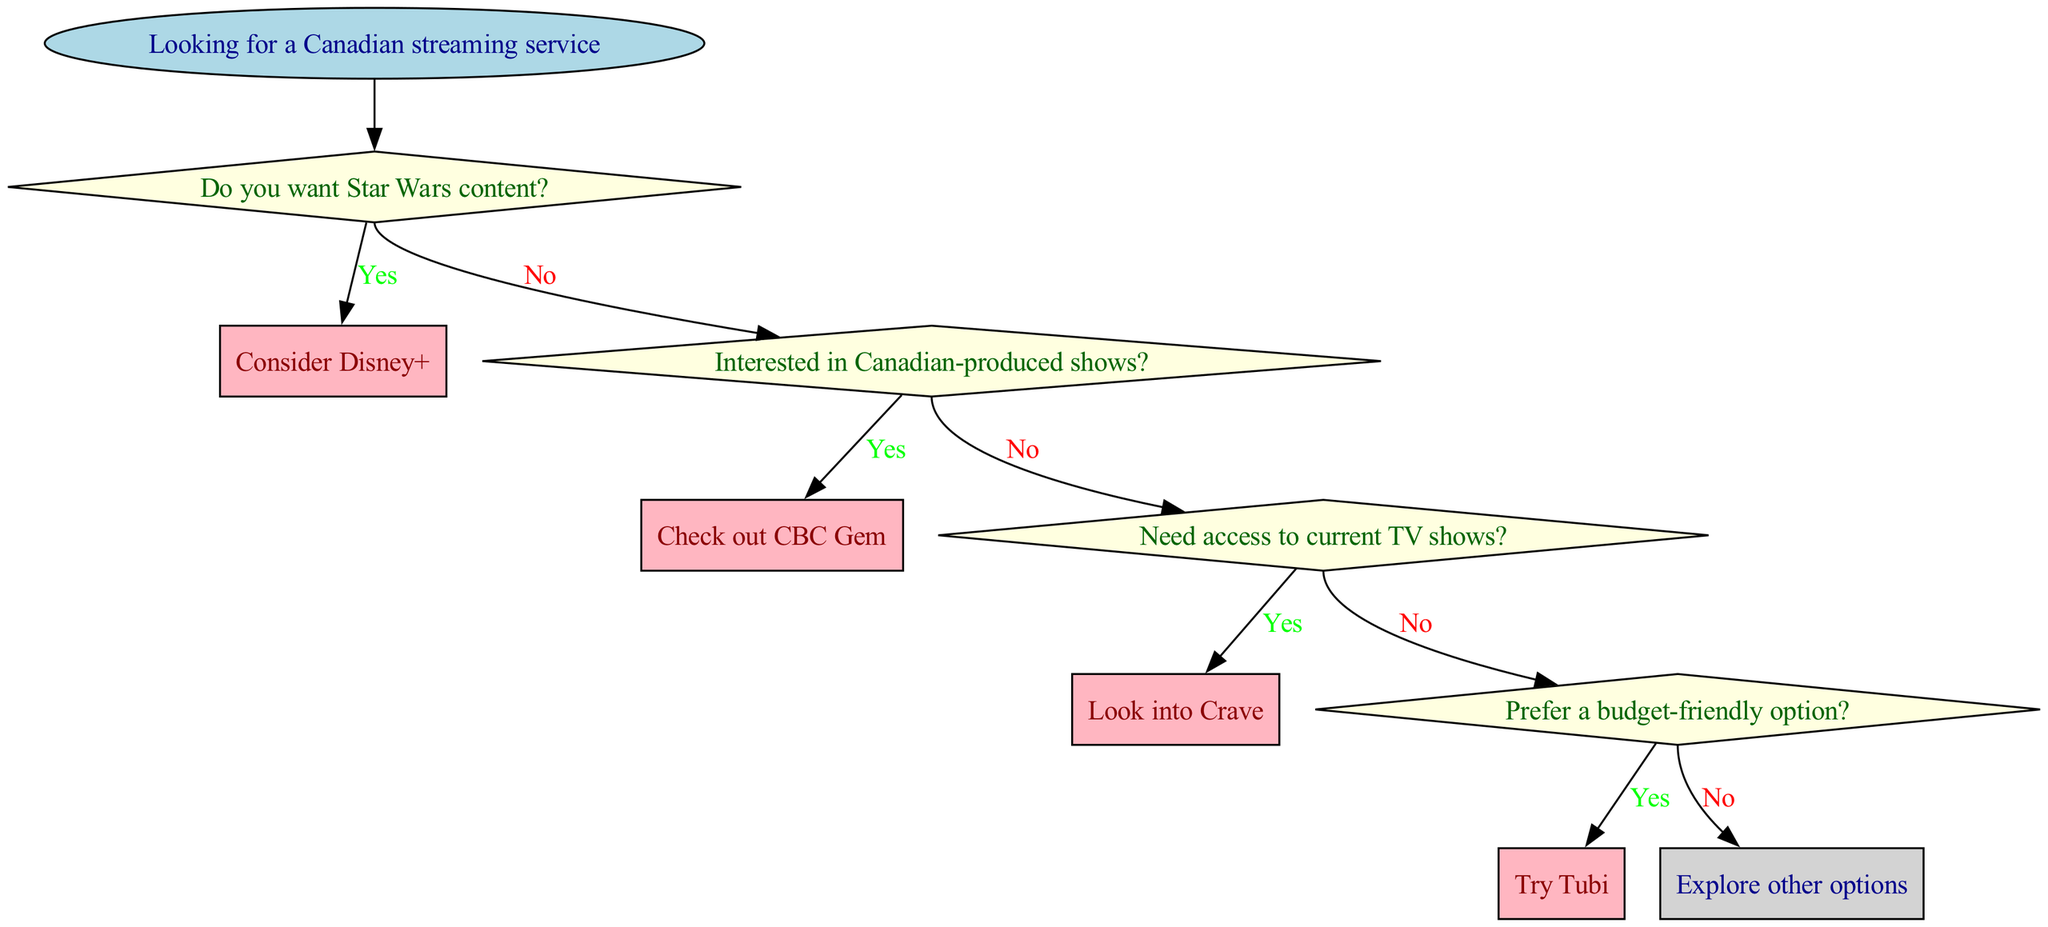What is the first question asked in the flowchart? The first question in the flowchart is directly linked to the starting point, which is "Do you want Star Wars content?" This is the first decision point in the flow.
Answer: Do you want Star Wars content? How many decisions are represented in the diagram? The diagram contains four decision nodes, where users have to answer questions to guide their selection of a streaming service. Each decision node corresponds to a unique question.
Answer: Four If a user answers "no" to the first question, what is the next question they will encounter? After a "no" answer to the first question about Star Wars content, the next question to be encountered is "Interested in Canadian-produced shows?" as it follows sequentially in the flow.
Answer: Interested in Canadian-produced shows? What happens if a user answers "yes" to the question about Canadian-produced shows? If a user answers "yes" to the question about Canadian-produced shows, they are directed to subscribe to CBC Gem, which is the endpoint for that decision.
Answer: Subscribe to CBC Gem What is the final endpoint if the user prefers a budget-friendly option? If the user prefers a budget-friendly option and answers "yes," they will be directed to try Tubi. However, if they answer "no" to that question, they will be directed to consider Netflix, which is the last endpoint in this decision sequence.
Answer: Try Tubi What color are the decision nodes in the flowchart? The decision nodes in the flowchart are filled with light yellow color, which distinguishes them from start and endpoint nodes. This color is specifically used for decision-making questions.
Answer: Light yellow What is the endpoint if the user doesn't want Star Wars content and isn't interested in Canadian-produced shows? If the user answers "no" to both the first and second questions, they will then proceed to the third question about access to current TV shows, thus leading to further decision-making but not directly resulting in an endpoint at this stage.
Answer: Proceed to next question How many endpoints are listed in the diagram? There are six endpoints listed in the diagram, representing the various actions a user can take based on their responses to the questions laid out in the flowchart.
Answer: Six 